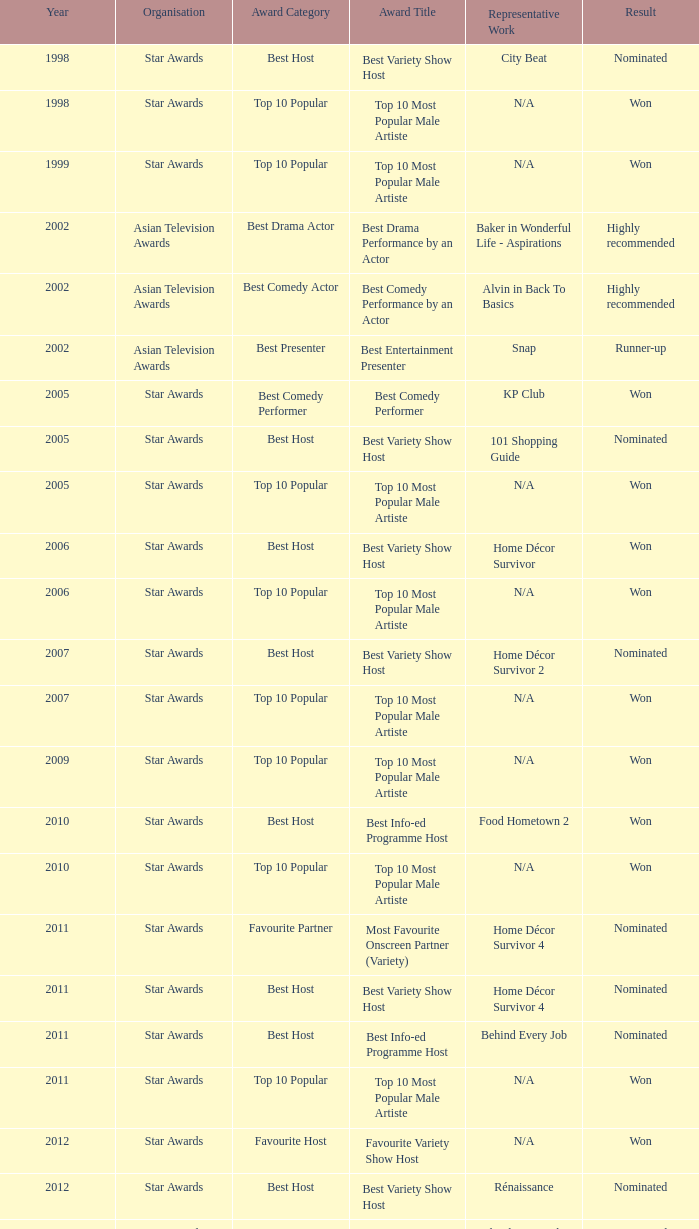What is the award for 1998 with Representative Work of city beat? Best Variety Show Host. 